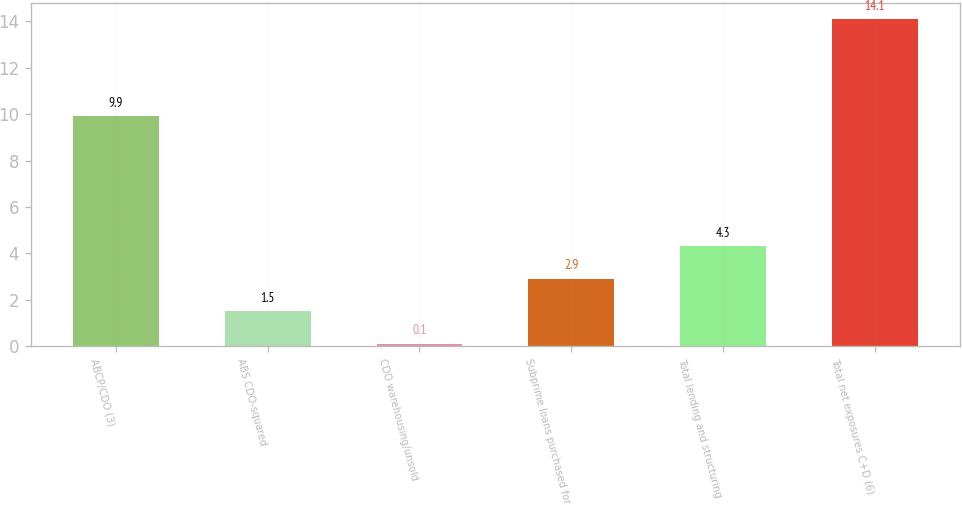Convert chart. <chart><loc_0><loc_0><loc_500><loc_500><bar_chart><fcel>ABCP/CDO (3)<fcel>ABS CDO-squared<fcel>CDO warehousing/unsold<fcel>Subprime loans purchased for<fcel>Total lending and structuring<fcel>Total net exposures C+D (6)<nl><fcel>9.9<fcel>1.5<fcel>0.1<fcel>2.9<fcel>4.3<fcel>14.1<nl></chart> 